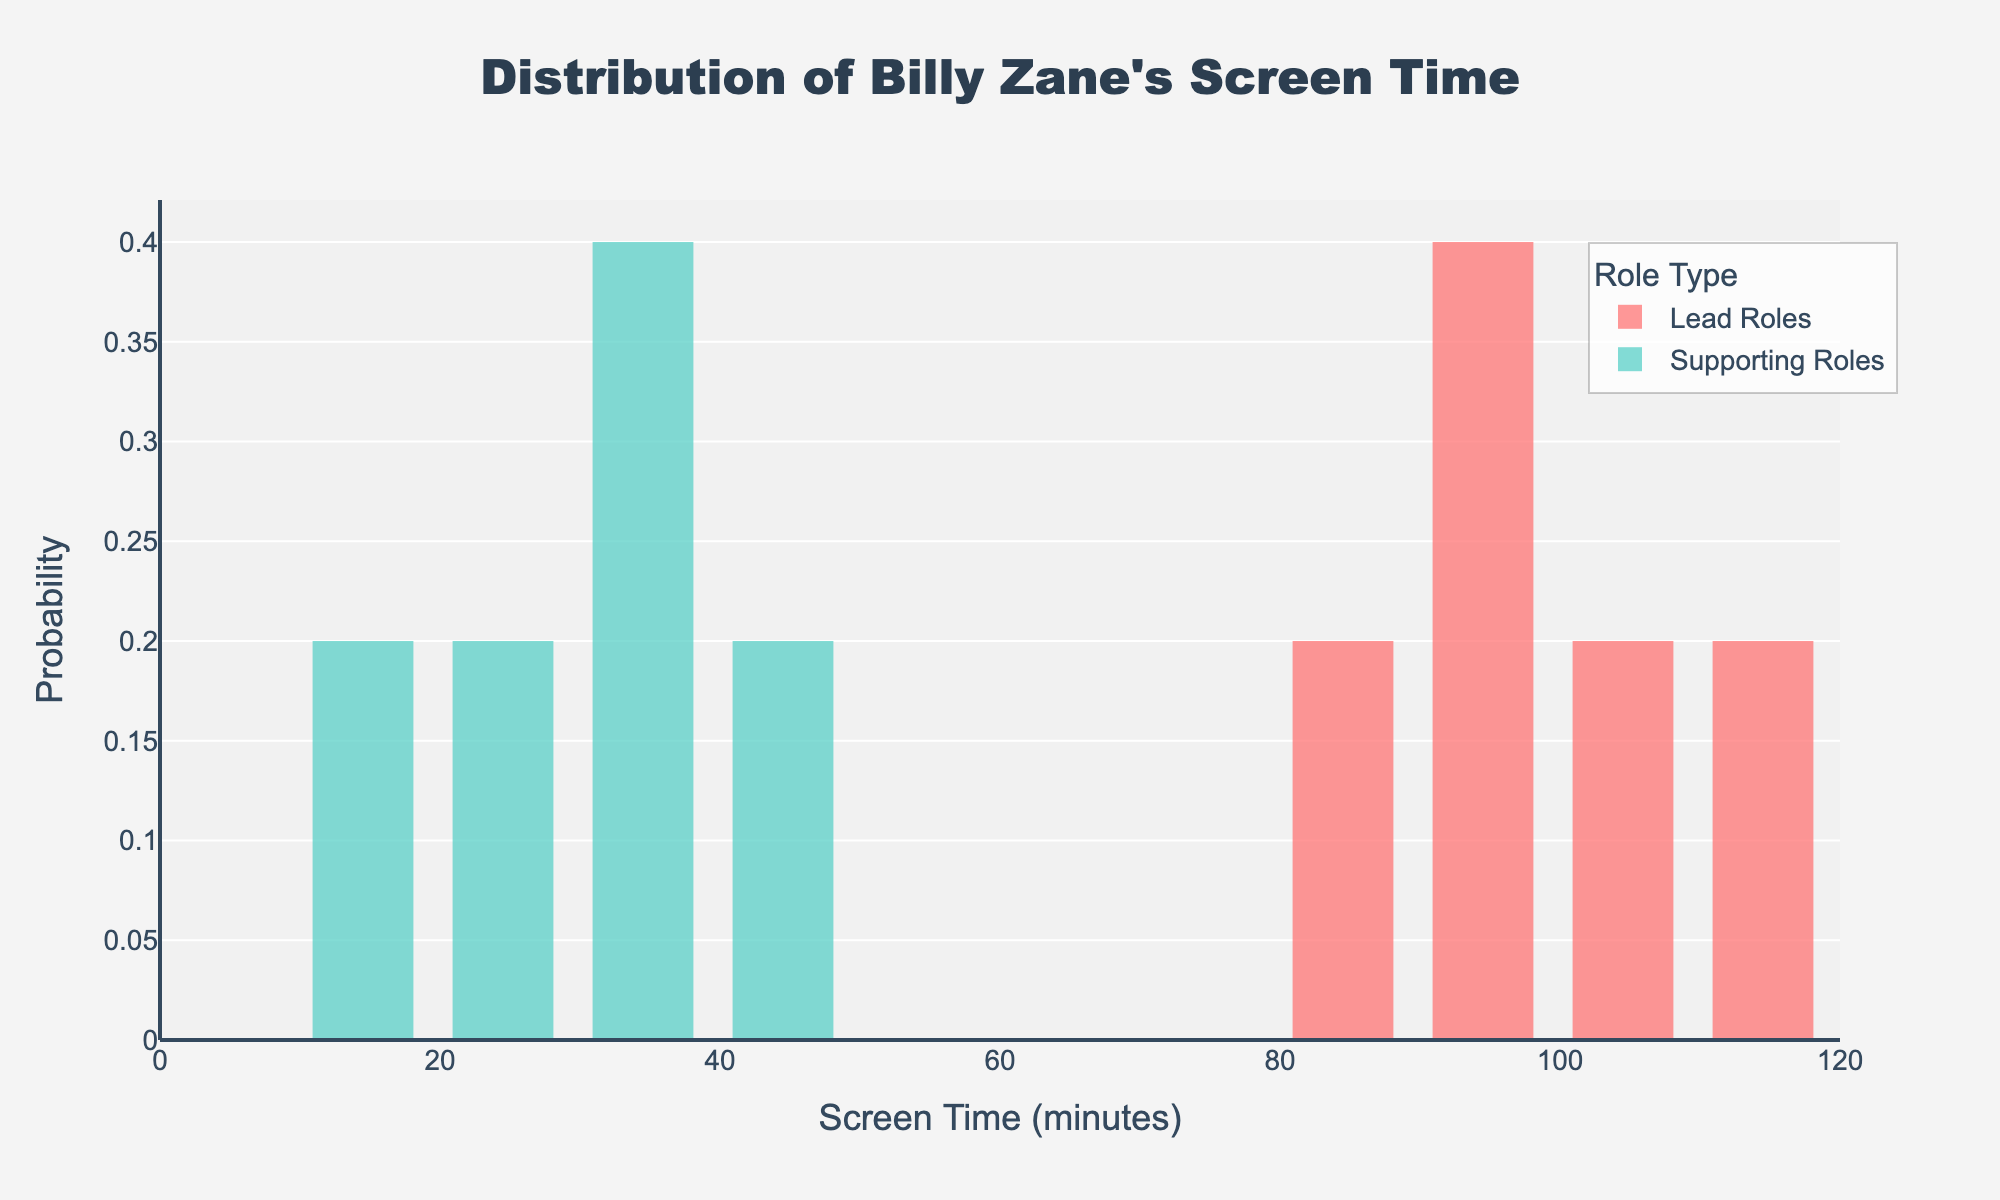What is the title of the plot? The title is usually positioned at the top of the plot and is often the largest text on the figure. It provides a summary of what the plot represents.
Answer: Distribution of Billy Zane's Screen Time What roles are compared in the figure? The roles compared are displayed in the legend typically positioned in the plot and described in the title.
Answer: Lead Roles and Supporting Roles Which role type has a higher peak in screen time probability? By observing the histogram bars, we can compare the height of the bars to determine which role type has a higher peak.
Answer: Lead Roles What is the range of screen time for lead roles? By looking at the x-axis values where the bars for lead roles are present, we can identify the minimum and maximum screen time.
Answer: 88 to 110 minutes What is the probability of Billy Zane having a screen time between 88 to 92 minutes for lead roles? Look at the histogram bar heights (y-axis) in the specified screen time range on the x-axis for lead roles.
Answer: Approximately 0.33 Which screen time bin has the lowest probability for supporting roles? Identify the histogram bar for supporting roles that is lowest in terms of its height (y-axis value).
Answer: 34 to 38 minutes How many movies did Billy Zane play as a supporting actor with screen time less than 20 minutes? Count the histogram bins for supporting roles that have any bar indicating non-zero probability below the 20-minute mark.
Answer: 1 movie What is the average screen time for Billy Zane's lead roles? Sum up the screen times for lead roles and divide by the number of lead roles.
Answer: (110 + 88 + 105 + 93 + 92) / 5 = 488 / 5 = 97.6 minutes What's the difference in the highest screen time between lead and supporting roles? Identify the highest screen time for both lead and supporting roles and then subtract the value for supporting roles from lead roles.
Answer: 110 - 42 = 68 minutes Which role type shows a greater spread in screen time values? Compare the range of screen time values by the width of the histogram bars spread across the x-axis for each role type.
Answer: Lead Roles 